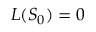Convert formula to latex. <formula><loc_0><loc_0><loc_500><loc_500>L ( S _ { 0 } ) = 0</formula> 